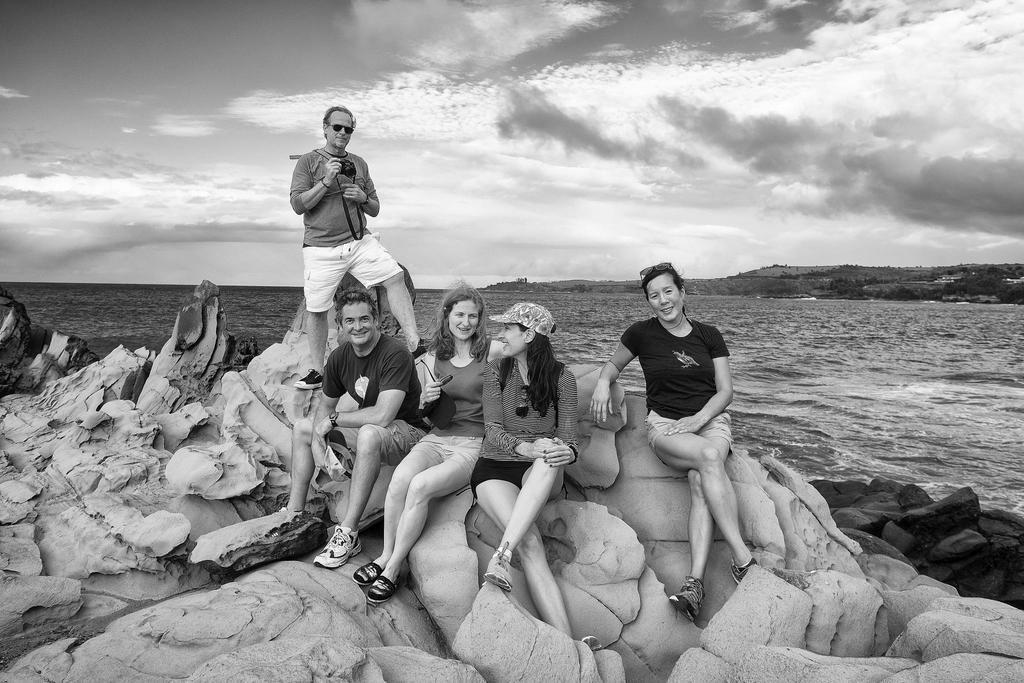Please provide a concise description of this image. This picture shows few people seated on the rocks and we see a man standing and holding camera in his hand and he wore sunglasses on his face and a woman wore cap on her head and another woman holding sunglasses in her hand and we see water, trees and a cloudy sky. 